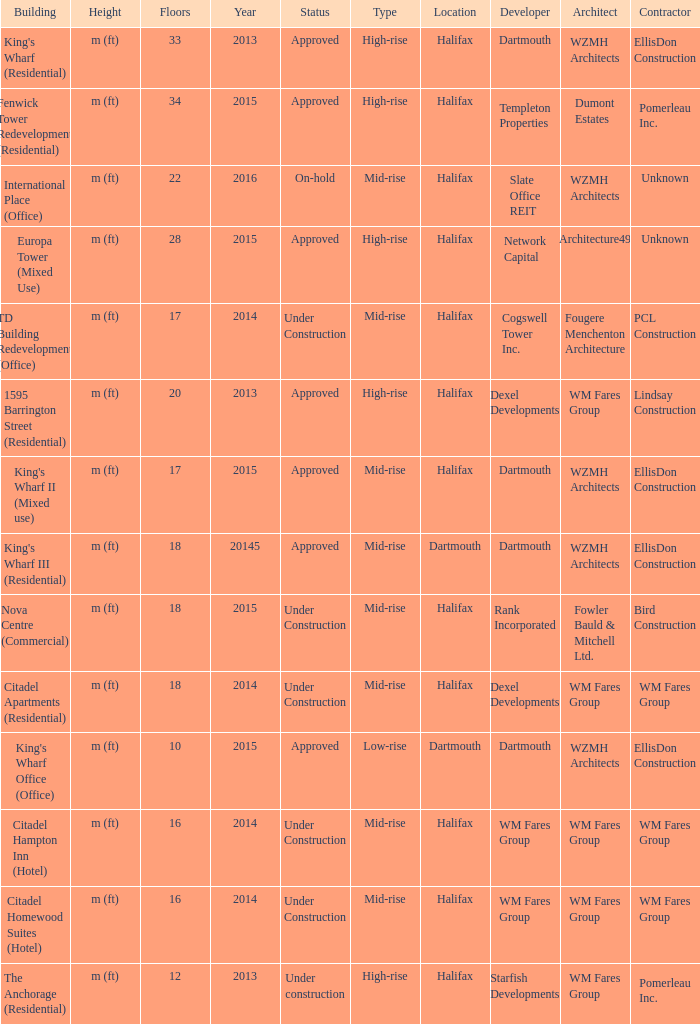What building shows 2013 and has more than 20 floors? King's Wharf (Residential). 